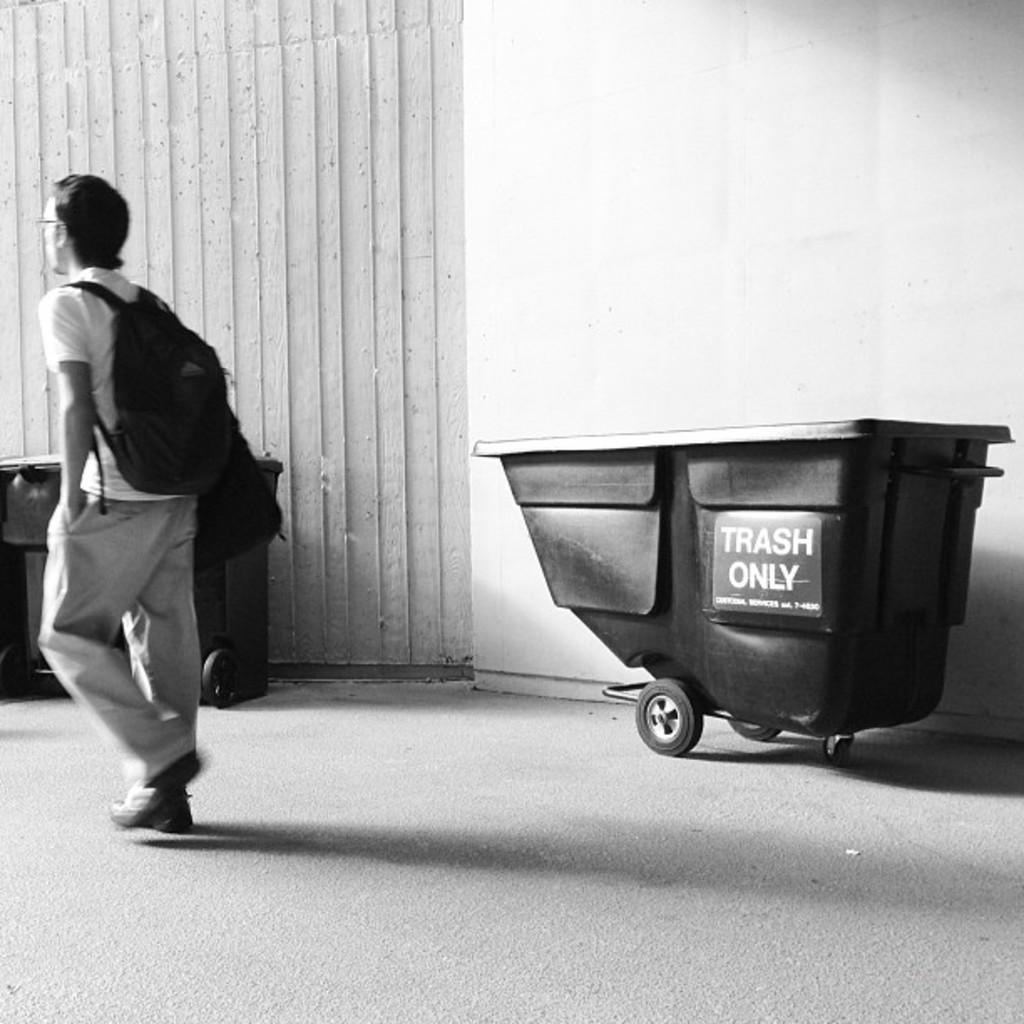What is the color scheme of the image? The image is black and white. Can you describe the person in the image? There is a person in the image, and they are wearing a bag. What can be seen in the background of the image? There are trash vehicles in the background of the image. What type of vegetable is being harvested by the chickens in the image? There are no chickens or vegetables present in the image; it features a person wearing a bag and trash vehicles in the background. 